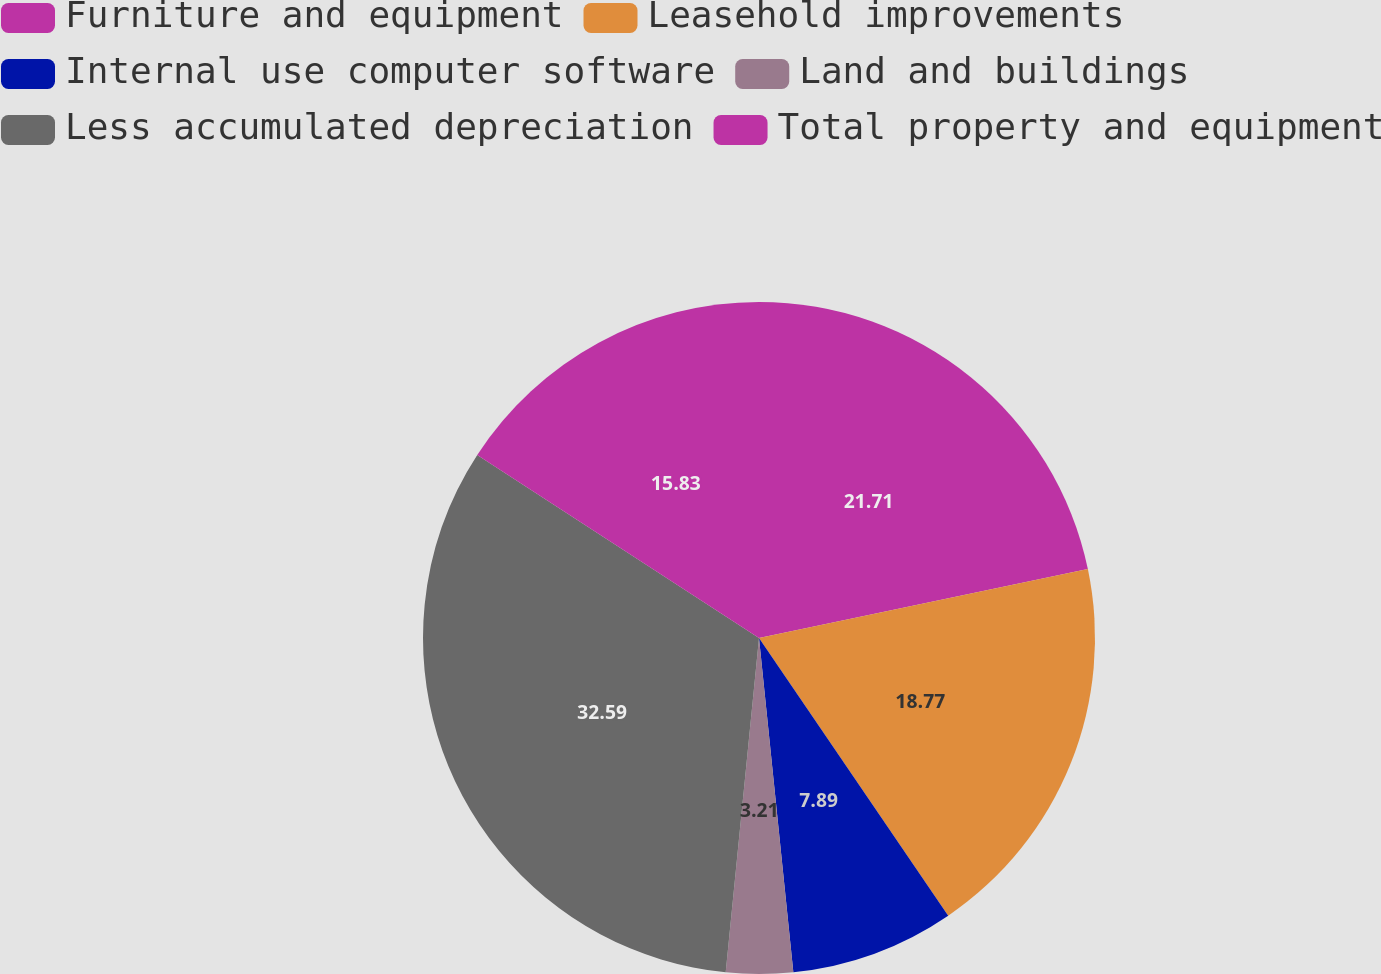Convert chart to OTSL. <chart><loc_0><loc_0><loc_500><loc_500><pie_chart><fcel>Furniture and equipment<fcel>Leasehold improvements<fcel>Internal use computer software<fcel>Land and buildings<fcel>Less accumulated depreciation<fcel>Total property and equipment<nl><fcel>21.71%<fcel>18.77%<fcel>7.89%<fcel>3.21%<fcel>32.59%<fcel>15.83%<nl></chart> 